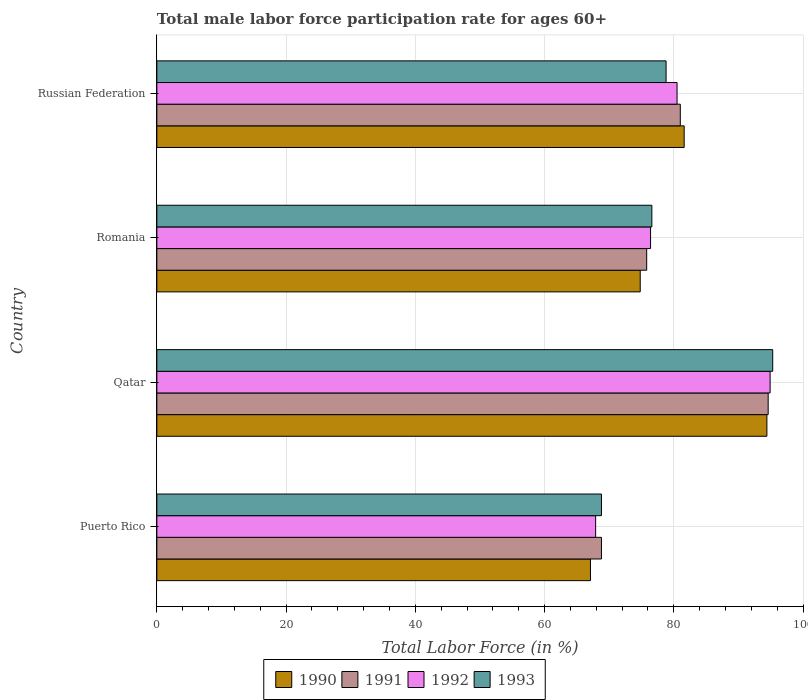Are the number of bars per tick equal to the number of legend labels?
Provide a short and direct response. Yes. What is the label of the 2nd group of bars from the top?
Your answer should be compact. Romania. What is the male labor force participation rate in 1992 in Puerto Rico?
Ensure brevity in your answer.  67.9. Across all countries, what is the maximum male labor force participation rate in 1991?
Your answer should be very brief. 94.6. Across all countries, what is the minimum male labor force participation rate in 1993?
Your response must be concise. 68.8. In which country was the male labor force participation rate in 1993 maximum?
Offer a very short reply. Qatar. In which country was the male labor force participation rate in 1991 minimum?
Give a very brief answer. Puerto Rico. What is the total male labor force participation rate in 1990 in the graph?
Make the answer very short. 317.9. What is the difference between the male labor force participation rate in 1992 in Russian Federation and the male labor force participation rate in 1991 in Qatar?
Keep it short and to the point. -14.1. What is the average male labor force participation rate in 1991 per country?
Provide a succinct answer. 80.05. What is the difference between the male labor force participation rate in 1992 and male labor force participation rate in 1990 in Romania?
Offer a very short reply. 1.6. What is the ratio of the male labor force participation rate in 1990 in Puerto Rico to that in Russian Federation?
Provide a succinct answer. 0.82. Is the male labor force participation rate in 1992 in Puerto Rico less than that in Qatar?
Your response must be concise. Yes. What is the difference between the highest and the second highest male labor force participation rate in 1990?
Offer a very short reply. 12.8. What is the difference between the highest and the lowest male labor force participation rate in 1993?
Offer a terse response. 26.5. In how many countries, is the male labor force participation rate in 1991 greater than the average male labor force participation rate in 1991 taken over all countries?
Ensure brevity in your answer.  2. Is it the case that in every country, the sum of the male labor force participation rate in 1993 and male labor force participation rate in 1992 is greater than the sum of male labor force participation rate in 1991 and male labor force participation rate in 1990?
Your answer should be very brief. No. What does the 3rd bar from the bottom in Puerto Rico represents?
Provide a short and direct response. 1992. Is it the case that in every country, the sum of the male labor force participation rate in 1990 and male labor force participation rate in 1993 is greater than the male labor force participation rate in 1992?
Provide a short and direct response. Yes. Are all the bars in the graph horizontal?
Make the answer very short. Yes. What is the difference between two consecutive major ticks on the X-axis?
Give a very brief answer. 20. Does the graph contain any zero values?
Give a very brief answer. No. Does the graph contain grids?
Provide a succinct answer. Yes. What is the title of the graph?
Make the answer very short. Total male labor force participation rate for ages 60+. Does "2009" appear as one of the legend labels in the graph?
Your answer should be compact. No. What is the label or title of the X-axis?
Ensure brevity in your answer.  Total Labor Force (in %). What is the Total Labor Force (in %) of 1990 in Puerto Rico?
Keep it short and to the point. 67.1. What is the Total Labor Force (in %) in 1991 in Puerto Rico?
Offer a terse response. 68.8. What is the Total Labor Force (in %) in 1992 in Puerto Rico?
Provide a short and direct response. 67.9. What is the Total Labor Force (in %) in 1993 in Puerto Rico?
Make the answer very short. 68.8. What is the Total Labor Force (in %) of 1990 in Qatar?
Make the answer very short. 94.4. What is the Total Labor Force (in %) in 1991 in Qatar?
Make the answer very short. 94.6. What is the Total Labor Force (in %) of 1992 in Qatar?
Your response must be concise. 94.9. What is the Total Labor Force (in %) of 1993 in Qatar?
Offer a terse response. 95.3. What is the Total Labor Force (in %) in 1990 in Romania?
Keep it short and to the point. 74.8. What is the Total Labor Force (in %) of 1991 in Romania?
Give a very brief answer. 75.8. What is the Total Labor Force (in %) of 1992 in Romania?
Ensure brevity in your answer.  76.4. What is the Total Labor Force (in %) of 1993 in Romania?
Offer a very short reply. 76.6. What is the Total Labor Force (in %) of 1990 in Russian Federation?
Your response must be concise. 81.6. What is the Total Labor Force (in %) of 1991 in Russian Federation?
Offer a terse response. 81. What is the Total Labor Force (in %) of 1992 in Russian Federation?
Your answer should be compact. 80.5. What is the Total Labor Force (in %) of 1993 in Russian Federation?
Offer a terse response. 78.8. Across all countries, what is the maximum Total Labor Force (in %) in 1990?
Keep it short and to the point. 94.4. Across all countries, what is the maximum Total Labor Force (in %) of 1991?
Offer a terse response. 94.6. Across all countries, what is the maximum Total Labor Force (in %) of 1992?
Your response must be concise. 94.9. Across all countries, what is the maximum Total Labor Force (in %) in 1993?
Your answer should be very brief. 95.3. Across all countries, what is the minimum Total Labor Force (in %) of 1990?
Your response must be concise. 67.1. Across all countries, what is the minimum Total Labor Force (in %) in 1991?
Provide a succinct answer. 68.8. Across all countries, what is the minimum Total Labor Force (in %) of 1992?
Your answer should be very brief. 67.9. Across all countries, what is the minimum Total Labor Force (in %) in 1993?
Keep it short and to the point. 68.8. What is the total Total Labor Force (in %) of 1990 in the graph?
Ensure brevity in your answer.  317.9. What is the total Total Labor Force (in %) in 1991 in the graph?
Your answer should be very brief. 320.2. What is the total Total Labor Force (in %) in 1992 in the graph?
Offer a terse response. 319.7. What is the total Total Labor Force (in %) in 1993 in the graph?
Offer a very short reply. 319.5. What is the difference between the Total Labor Force (in %) in 1990 in Puerto Rico and that in Qatar?
Provide a short and direct response. -27.3. What is the difference between the Total Labor Force (in %) of 1991 in Puerto Rico and that in Qatar?
Ensure brevity in your answer.  -25.8. What is the difference between the Total Labor Force (in %) of 1992 in Puerto Rico and that in Qatar?
Your answer should be very brief. -27. What is the difference between the Total Labor Force (in %) of 1993 in Puerto Rico and that in Qatar?
Your response must be concise. -26.5. What is the difference between the Total Labor Force (in %) of 1992 in Puerto Rico and that in Romania?
Give a very brief answer. -8.5. What is the difference between the Total Labor Force (in %) in 1993 in Puerto Rico and that in Romania?
Make the answer very short. -7.8. What is the difference between the Total Labor Force (in %) in 1991 in Puerto Rico and that in Russian Federation?
Give a very brief answer. -12.2. What is the difference between the Total Labor Force (in %) of 1992 in Puerto Rico and that in Russian Federation?
Your answer should be very brief. -12.6. What is the difference between the Total Labor Force (in %) of 1990 in Qatar and that in Romania?
Keep it short and to the point. 19.6. What is the difference between the Total Labor Force (in %) of 1993 in Qatar and that in Romania?
Offer a very short reply. 18.7. What is the difference between the Total Labor Force (in %) of 1990 in Qatar and that in Russian Federation?
Keep it short and to the point. 12.8. What is the difference between the Total Labor Force (in %) in 1992 in Qatar and that in Russian Federation?
Provide a succinct answer. 14.4. What is the difference between the Total Labor Force (in %) in 1993 in Romania and that in Russian Federation?
Your answer should be compact. -2.2. What is the difference between the Total Labor Force (in %) of 1990 in Puerto Rico and the Total Labor Force (in %) of 1991 in Qatar?
Keep it short and to the point. -27.5. What is the difference between the Total Labor Force (in %) of 1990 in Puerto Rico and the Total Labor Force (in %) of 1992 in Qatar?
Ensure brevity in your answer.  -27.8. What is the difference between the Total Labor Force (in %) of 1990 in Puerto Rico and the Total Labor Force (in %) of 1993 in Qatar?
Give a very brief answer. -28.2. What is the difference between the Total Labor Force (in %) in 1991 in Puerto Rico and the Total Labor Force (in %) in 1992 in Qatar?
Make the answer very short. -26.1. What is the difference between the Total Labor Force (in %) in 1991 in Puerto Rico and the Total Labor Force (in %) in 1993 in Qatar?
Offer a terse response. -26.5. What is the difference between the Total Labor Force (in %) in 1992 in Puerto Rico and the Total Labor Force (in %) in 1993 in Qatar?
Make the answer very short. -27.4. What is the difference between the Total Labor Force (in %) of 1990 in Puerto Rico and the Total Labor Force (in %) of 1992 in Romania?
Provide a succinct answer. -9.3. What is the difference between the Total Labor Force (in %) in 1990 in Puerto Rico and the Total Labor Force (in %) in 1993 in Romania?
Your answer should be compact. -9.5. What is the difference between the Total Labor Force (in %) of 1991 in Puerto Rico and the Total Labor Force (in %) of 1992 in Romania?
Keep it short and to the point. -7.6. What is the difference between the Total Labor Force (in %) of 1992 in Puerto Rico and the Total Labor Force (in %) of 1993 in Romania?
Provide a short and direct response. -8.7. What is the difference between the Total Labor Force (in %) in 1990 in Puerto Rico and the Total Labor Force (in %) in 1993 in Russian Federation?
Your answer should be very brief. -11.7. What is the difference between the Total Labor Force (in %) of 1991 in Puerto Rico and the Total Labor Force (in %) of 1992 in Russian Federation?
Your answer should be very brief. -11.7. What is the difference between the Total Labor Force (in %) of 1992 in Puerto Rico and the Total Labor Force (in %) of 1993 in Russian Federation?
Your answer should be very brief. -10.9. What is the difference between the Total Labor Force (in %) of 1991 in Qatar and the Total Labor Force (in %) of 1992 in Romania?
Offer a terse response. 18.2. What is the difference between the Total Labor Force (in %) in 1991 in Qatar and the Total Labor Force (in %) in 1993 in Romania?
Provide a short and direct response. 18. What is the difference between the Total Labor Force (in %) of 1992 in Qatar and the Total Labor Force (in %) of 1993 in Romania?
Your answer should be very brief. 18.3. What is the difference between the Total Labor Force (in %) of 1990 in Qatar and the Total Labor Force (in %) of 1991 in Russian Federation?
Keep it short and to the point. 13.4. What is the difference between the Total Labor Force (in %) of 1990 in Qatar and the Total Labor Force (in %) of 1992 in Russian Federation?
Provide a succinct answer. 13.9. What is the difference between the Total Labor Force (in %) of 1991 in Qatar and the Total Labor Force (in %) of 1992 in Russian Federation?
Make the answer very short. 14.1. What is the difference between the Total Labor Force (in %) of 1992 in Qatar and the Total Labor Force (in %) of 1993 in Russian Federation?
Offer a very short reply. 16.1. What is the difference between the Total Labor Force (in %) of 1990 in Romania and the Total Labor Force (in %) of 1991 in Russian Federation?
Offer a very short reply. -6.2. What is the difference between the Total Labor Force (in %) of 1992 in Romania and the Total Labor Force (in %) of 1993 in Russian Federation?
Make the answer very short. -2.4. What is the average Total Labor Force (in %) in 1990 per country?
Give a very brief answer. 79.47. What is the average Total Labor Force (in %) of 1991 per country?
Offer a very short reply. 80.05. What is the average Total Labor Force (in %) of 1992 per country?
Make the answer very short. 79.92. What is the average Total Labor Force (in %) in 1993 per country?
Offer a terse response. 79.88. What is the difference between the Total Labor Force (in %) of 1991 and Total Labor Force (in %) of 1992 in Puerto Rico?
Offer a very short reply. 0.9. What is the difference between the Total Labor Force (in %) of 1990 and Total Labor Force (in %) of 1991 in Qatar?
Provide a succinct answer. -0.2. What is the difference between the Total Labor Force (in %) of 1990 and Total Labor Force (in %) of 1992 in Qatar?
Offer a terse response. -0.5. What is the difference between the Total Labor Force (in %) in 1991 and Total Labor Force (in %) in 1993 in Qatar?
Give a very brief answer. -0.7. What is the difference between the Total Labor Force (in %) of 1991 and Total Labor Force (in %) of 1992 in Romania?
Your answer should be very brief. -0.6. What is the difference between the Total Labor Force (in %) in 1992 and Total Labor Force (in %) in 1993 in Romania?
Make the answer very short. -0.2. What is the difference between the Total Labor Force (in %) of 1990 and Total Labor Force (in %) of 1993 in Russian Federation?
Offer a terse response. 2.8. What is the difference between the Total Labor Force (in %) in 1991 and Total Labor Force (in %) in 1992 in Russian Federation?
Your response must be concise. 0.5. What is the difference between the Total Labor Force (in %) in 1991 and Total Labor Force (in %) in 1993 in Russian Federation?
Ensure brevity in your answer.  2.2. What is the difference between the Total Labor Force (in %) of 1992 and Total Labor Force (in %) of 1993 in Russian Federation?
Make the answer very short. 1.7. What is the ratio of the Total Labor Force (in %) of 1990 in Puerto Rico to that in Qatar?
Provide a succinct answer. 0.71. What is the ratio of the Total Labor Force (in %) of 1991 in Puerto Rico to that in Qatar?
Provide a succinct answer. 0.73. What is the ratio of the Total Labor Force (in %) of 1992 in Puerto Rico to that in Qatar?
Make the answer very short. 0.72. What is the ratio of the Total Labor Force (in %) in 1993 in Puerto Rico to that in Qatar?
Your answer should be compact. 0.72. What is the ratio of the Total Labor Force (in %) in 1990 in Puerto Rico to that in Romania?
Provide a short and direct response. 0.9. What is the ratio of the Total Labor Force (in %) of 1991 in Puerto Rico to that in Romania?
Your answer should be compact. 0.91. What is the ratio of the Total Labor Force (in %) in 1992 in Puerto Rico to that in Romania?
Provide a succinct answer. 0.89. What is the ratio of the Total Labor Force (in %) of 1993 in Puerto Rico to that in Romania?
Ensure brevity in your answer.  0.9. What is the ratio of the Total Labor Force (in %) in 1990 in Puerto Rico to that in Russian Federation?
Your response must be concise. 0.82. What is the ratio of the Total Labor Force (in %) in 1991 in Puerto Rico to that in Russian Federation?
Offer a terse response. 0.85. What is the ratio of the Total Labor Force (in %) in 1992 in Puerto Rico to that in Russian Federation?
Provide a succinct answer. 0.84. What is the ratio of the Total Labor Force (in %) of 1993 in Puerto Rico to that in Russian Federation?
Offer a terse response. 0.87. What is the ratio of the Total Labor Force (in %) of 1990 in Qatar to that in Romania?
Provide a short and direct response. 1.26. What is the ratio of the Total Labor Force (in %) in 1991 in Qatar to that in Romania?
Your answer should be very brief. 1.25. What is the ratio of the Total Labor Force (in %) of 1992 in Qatar to that in Romania?
Give a very brief answer. 1.24. What is the ratio of the Total Labor Force (in %) in 1993 in Qatar to that in Romania?
Keep it short and to the point. 1.24. What is the ratio of the Total Labor Force (in %) in 1990 in Qatar to that in Russian Federation?
Give a very brief answer. 1.16. What is the ratio of the Total Labor Force (in %) in 1991 in Qatar to that in Russian Federation?
Give a very brief answer. 1.17. What is the ratio of the Total Labor Force (in %) in 1992 in Qatar to that in Russian Federation?
Your response must be concise. 1.18. What is the ratio of the Total Labor Force (in %) in 1993 in Qatar to that in Russian Federation?
Provide a succinct answer. 1.21. What is the ratio of the Total Labor Force (in %) of 1991 in Romania to that in Russian Federation?
Your response must be concise. 0.94. What is the ratio of the Total Labor Force (in %) in 1992 in Romania to that in Russian Federation?
Provide a succinct answer. 0.95. What is the ratio of the Total Labor Force (in %) of 1993 in Romania to that in Russian Federation?
Ensure brevity in your answer.  0.97. What is the difference between the highest and the second highest Total Labor Force (in %) in 1991?
Your response must be concise. 13.6. What is the difference between the highest and the second highest Total Labor Force (in %) of 1993?
Offer a terse response. 16.5. What is the difference between the highest and the lowest Total Labor Force (in %) in 1990?
Make the answer very short. 27.3. What is the difference between the highest and the lowest Total Labor Force (in %) of 1991?
Provide a short and direct response. 25.8. What is the difference between the highest and the lowest Total Labor Force (in %) in 1992?
Offer a terse response. 27. What is the difference between the highest and the lowest Total Labor Force (in %) in 1993?
Give a very brief answer. 26.5. 